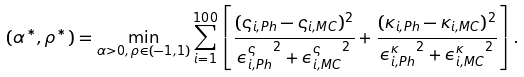Convert formula to latex. <formula><loc_0><loc_0><loc_500><loc_500>( \alpha ^ { * } , \rho ^ { * } ) = \min _ { \alpha > 0 , \, \rho \in ( - 1 , 1 ) } \sum _ { i = 1 } ^ { 1 0 0 } \left [ \frac { ( \varsigma _ { i , P h } - \varsigma _ { i , M C } ) ^ { 2 } } { { \epsilon _ { i , P h } ^ { \varsigma } } ^ { 2 } + { \epsilon _ { i , M C } ^ { \varsigma } } ^ { 2 } } + \frac { ( \kappa _ { i , P h } - \kappa _ { i , M C } ) ^ { 2 } } { { \epsilon _ { i , P h } ^ { \kappa } } ^ { 2 } + { \epsilon _ { i , M C } ^ { \kappa } } ^ { 2 } } \right ] .</formula> 